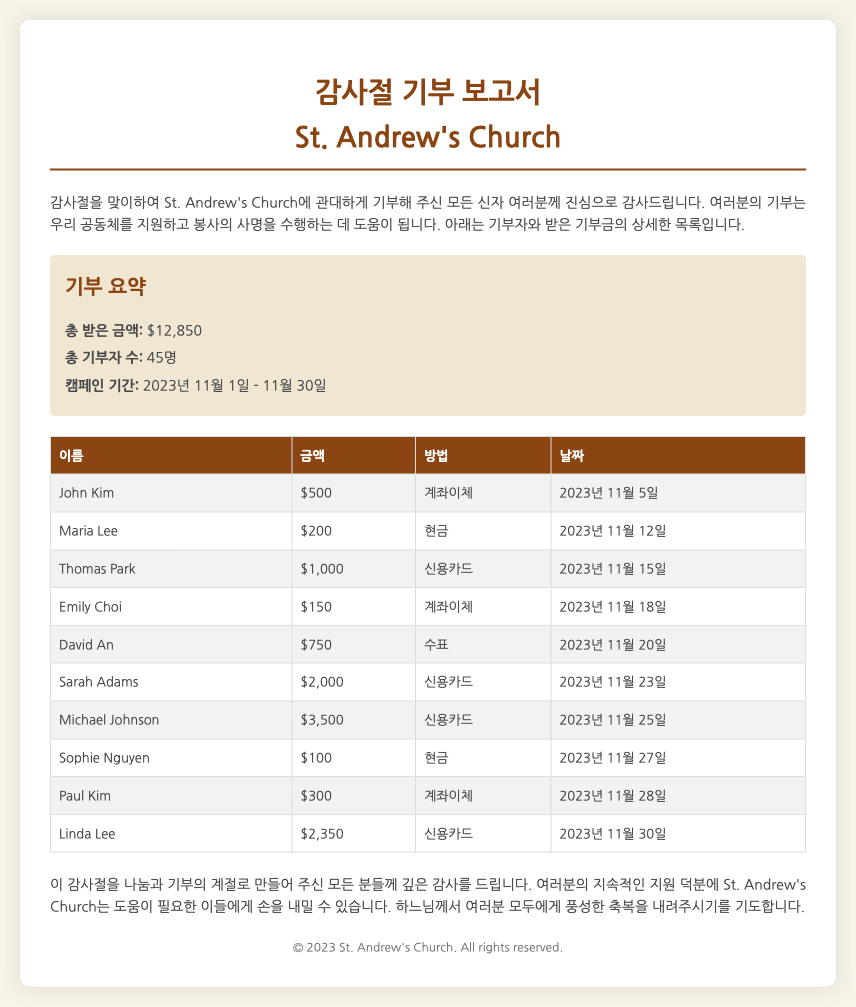What is the total amount received? The total amount received is clearly stated in the summary section of the document.
Answer: $12,850 How many contributors are there? The document specifies the total number of contributors in the summary.
Answer: 45명 What is the highest donation amount? To find the highest donation, we check the list of donations; it is the largest value shown in the table.
Answer: $3,500 Who donated $2,350? We can locate this information by looking through the list of contributors and their respective donation amounts.
Answer: Linda Lee On what date was the donation by Thomas Park made? The specific date for Thomas Park's donation is provided in the associated table.
Answer: 2023년 11월 15일 What payment method did Sarah Adams use? This information can be found next to Sarah Adams' donation entry in the table.
Answer: 신용카드 What is the campaign period for the donations? The campaign period is mentioned in the summary section of the report.
Answer: 2023년 11월 1일 - 11월 30일 How much did John Kim donate? John's donation amount is explicitly mentioned in the donation list.
Answer: $500 What does the introduction thank the contributors for? The introduction states the purpose of thanking the contributors specifically; it relates to their donations.
Answer: 기부 